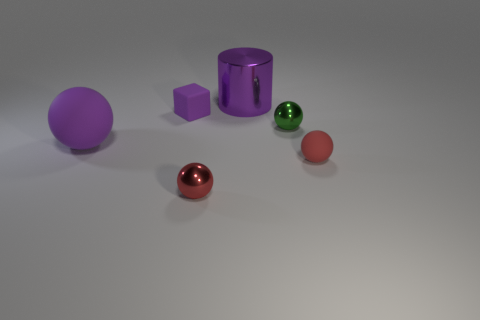Subtract all red shiny spheres. How many spheres are left? 3 Subtract all blue cylinders. How many red balls are left? 2 Add 1 tiny red balls. How many objects exist? 7 Subtract all red spheres. How many spheres are left? 2 Subtract all blocks. How many objects are left? 5 Subtract 1 balls. How many balls are left? 3 Add 5 purple matte cubes. How many purple matte cubes are left? 6 Add 4 purple cylinders. How many purple cylinders exist? 5 Subtract 0 cyan cubes. How many objects are left? 6 Subtract all yellow cubes. Subtract all brown spheres. How many cubes are left? 1 